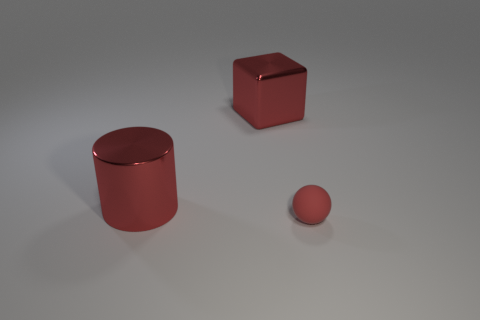Add 2 large gray metallic things. How many objects exist? 5 Subtract 1 cylinders. How many cylinders are left? 0 Subtract all spheres. How many objects are left? 2 Subtract 0 blue cylinders. How many objects are left? 3 Subtract all red metal cylinders. Subtract all metallic cylinders. How many objects are left? 1 Add 3 red objects. How many red objects are left? 6 Add 2 red shiny cubes. How many red shiny cubes exist? 3 